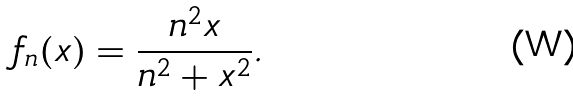Convert formula to latex. <formula><loc_0><loc_0><loc_500><loc_500>f _ { n } ( x ) = \frac { n ^ { 2 } x } { n ^ { 2 } + x ^ { 2 } } .</formula> 